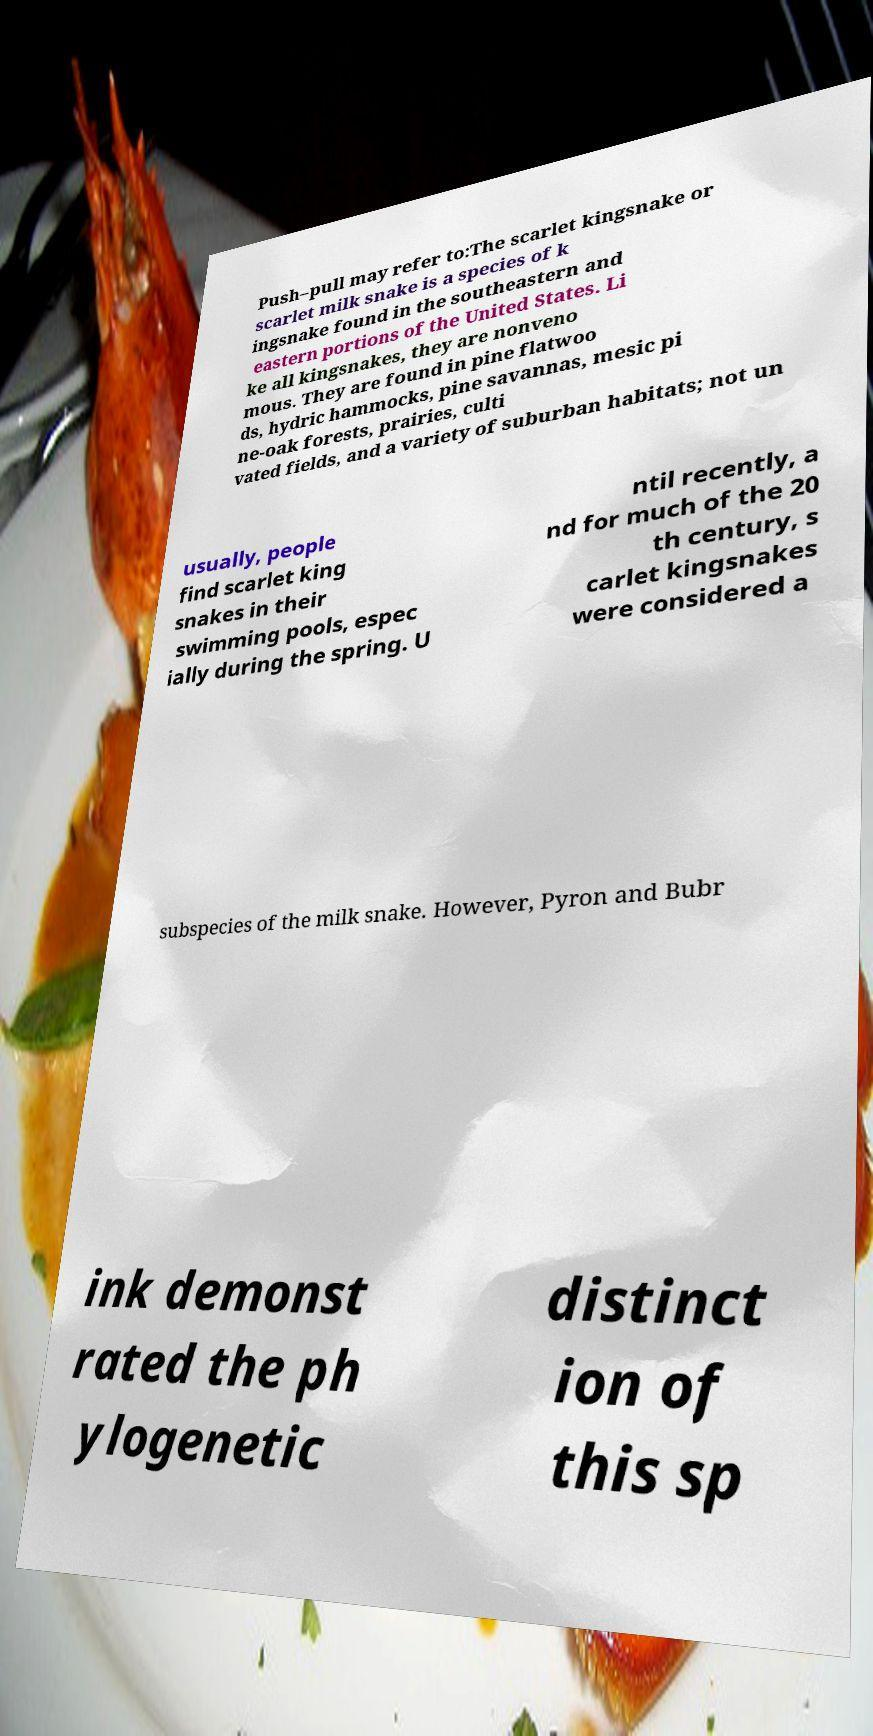Please identify and transcribe the text found in this image. Push–pull may refer to:The scarlet kingsnake or scarlet milk snake is a species of k ingsnake found in the southeastern and eastern portions of the United States. Li ke all kingsnakes, they are nonveno mous. They are found in pine flatwoo ds, hydric hammocks, pine savannas, mesic pi ne-oak forests, prairies, culti vated fields, and a variety of suburban habitats; not un usually, people find scarlet king snakes in their swimming pools, espec ially during the spring. U ntil recently, a nd for much of the 20 th century, s carlet kingsnakes were considered a subspecies of the milk snake. However, Pyron and Bubr ink demonst rated the ph ylogenetic distinct ion of this sp 